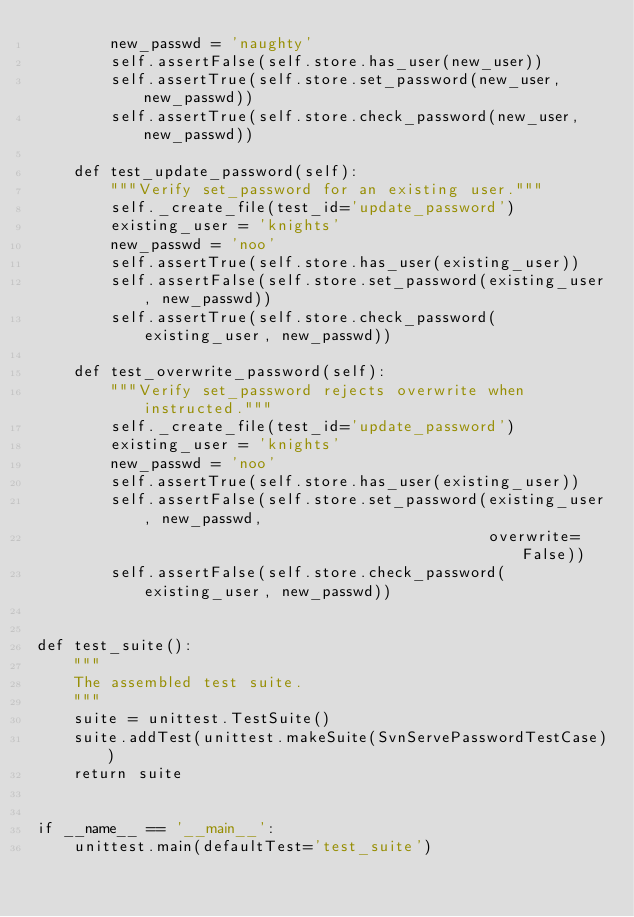Convert code to text. <code><loc_0><loc_0><loc_500><loc_500><_Python_>        new_passwd = 'naughty'
        self.assertFalse(self.store.has_user(new_user))
        self.assertTrue(self.store.set_password(new_user, new_passwd))
        self.assertTrue(self.store.check_password(new_user, new_passwd))

    def test_update_password(self):
        """Verify set_password for an existing user."""
        self._create_file(test_id='update_password')
        existing_user = 'knights'
        new_passwd = 'noo'
        self.assertTrue(self.store.has_user(existing_user))
        self.assertFalse(self.store.set_password(existing_user, new_passwd))
        self.assertTrue(self.store.check_password(existing_user, new_passwd))

    def test_overwrite_password(self):
        """Verify set_password rejects overwrite when instructed."""
        self._create_file(test_id='update_password')
        existing_user = 'knights'
        new_passwd = 'noo'
        self.assertTrue(self.store.has_user(existing_user))
        self.assertFalse(self.store.set_password(existing_user, new_passwd,
                                                 overwrite=False))
        self.assertFalse(self.store.check_password(existing_user, new_passwd))


def test_suite():
    """
    The assembled test suite.
    """
    suite = unittest.TestSuite()
    suite.addTest(unittest.makeSuite(SvnServePasswordTestCase))
    return suite


if __name__ == '__main__':
    unittest.main(defaultTest='test_suite')
</code> 